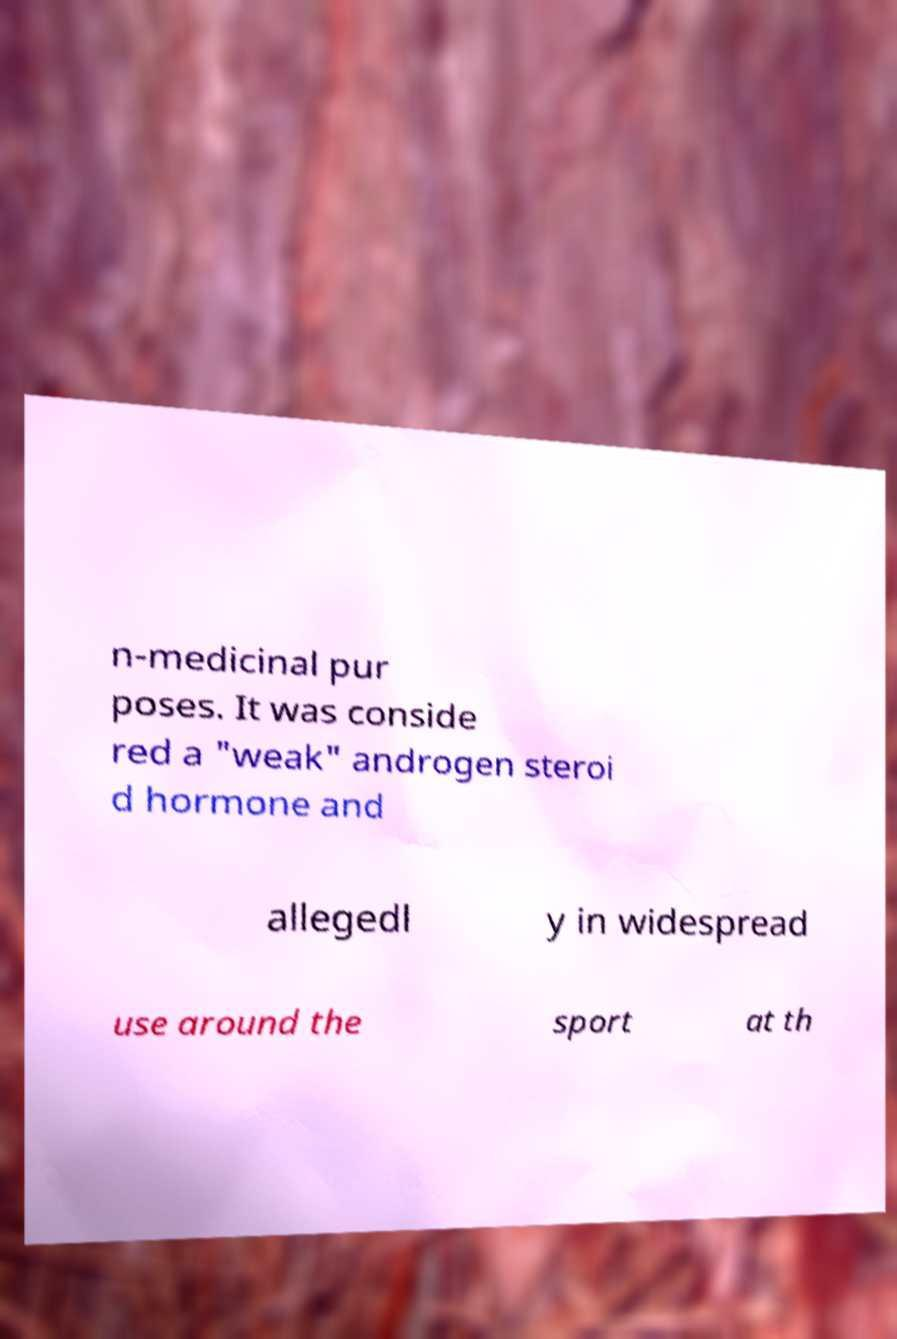Please read and relay the text visible in this image. What does it say? n-medicinal pur poses. It was conside red a "weak" androgen steroi d hormone and allegedl y in widespread use around the sport at th 